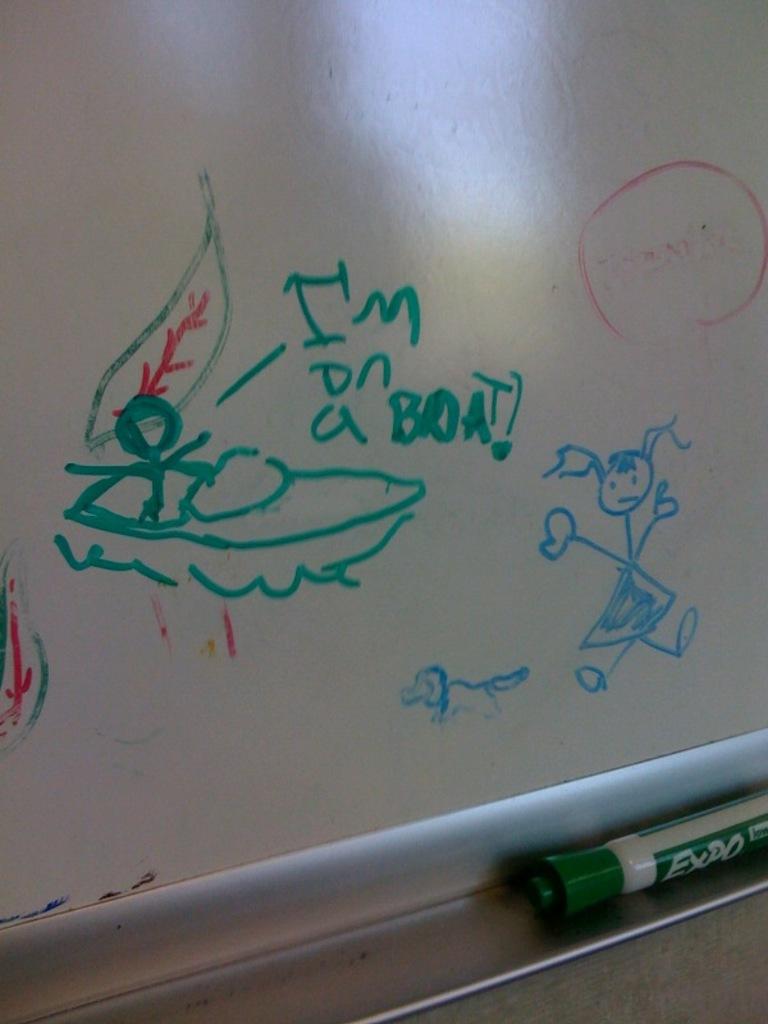What is the character on the boat saying?
Your response must be concise. I'm on a boat. Is there any text other than what's written in green?
Make the answer very short. No. 